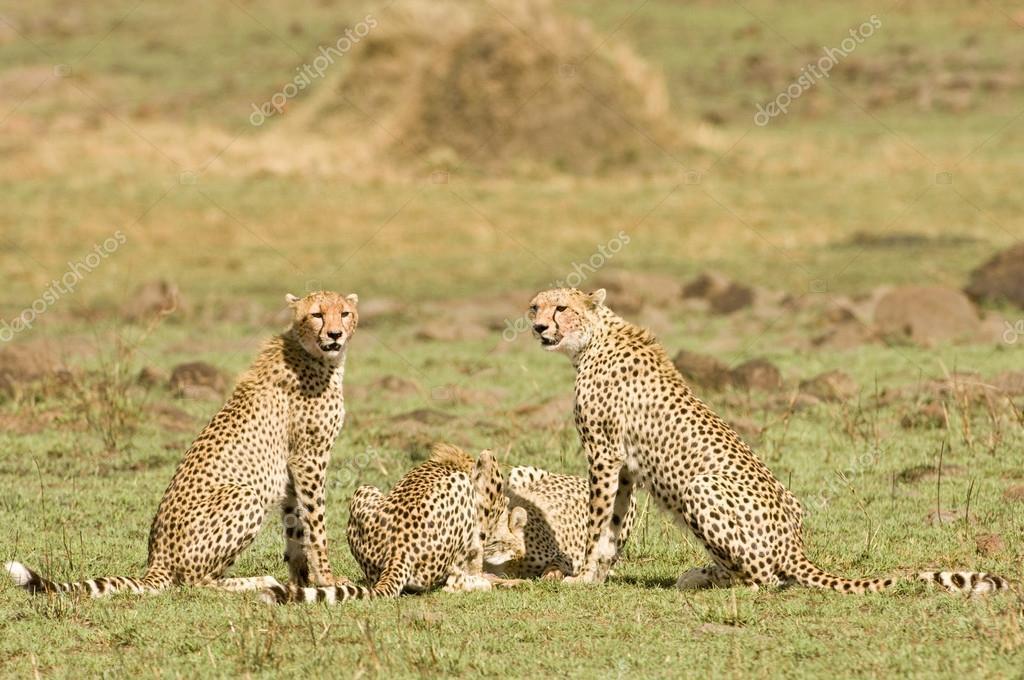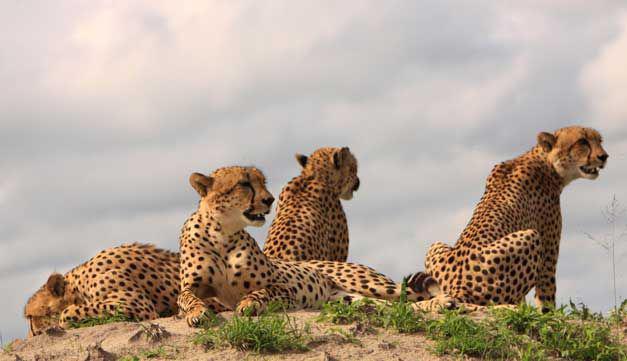The first image is the image on the left, the second image is the image on the right. For the images shown, is this caption "One of the images shows exactly two leopards." true? Answer yes or no. No. 